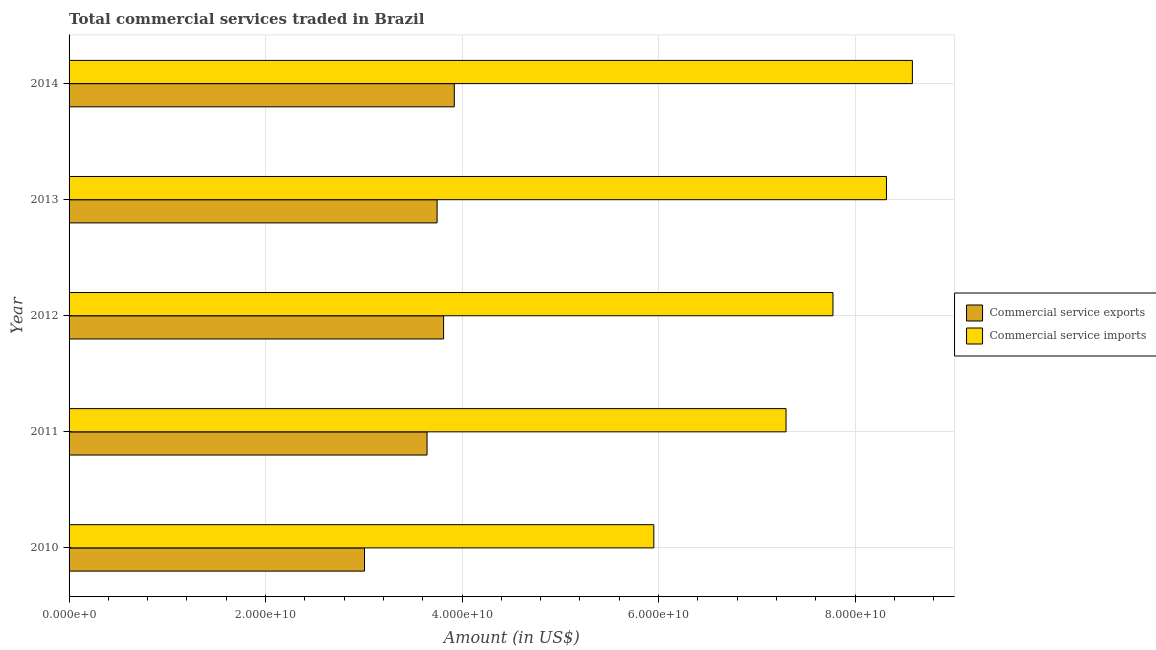How many different coloured bars are there?
Offer a very short reply. 2. Are the number of bars per tick equal to the number of legend labels?
Offer a terse response. Yes. Are the number of bars on each tick of the Y-axis equal?
Provide a short and direct response. Yes. How many bars are there on the 1st tick from the top?
Offer a terse response. 2. How many bars are there on the 4th tick from the bottom?
Make the answer very short. 2. What is the label of the 2nd group of bars from the top?
Provide a succinct answer. 2013. What is the amount of commercial service exports in 2010?
Give a very brief answer. 3.01e+1. Across all years, what is the maximum amount of commercial service imports?
Make the answer very short. 8.58e+1. Across all years, what is the minimum amount of commercial service exports?
Make the answer very short. 3.01e+1. In which year was the amount of commercial service imports maximum?
Provide a short and direct response. 2014. In which year was the amount of commercial service imports minimum?
Provide a succinct answer. 2010. What is the total amount of commercial service exports in the graph?
Ensure brevity in your answer.  1.81e+11. What is the difference between the amount of commercial service exports in 2011 and that in 2013?
Offer a very short reply. -1.02e+09. What is the difference between the amount of commercial service exports in 2014 and the amount of commercial service imports in 2011?
Provide a short and direct response. -3.38e+1. What is the average amount of commercial service exports per year?
Offer a very short reply. 3.63e+1. In the year 2014, what is the difference between the amount of commercial service exports and amount of commercial service imports?
Ensure brevity in your answer.  -4.66e+1. In how many years, is the amount of commercial service exports greater than 28000000000 US$?
Provide a short and direct response. 5. What is the ratio of the amount of commercial service imports in 2010 to that in 2014?
Provide a short and direct response. 0.69. Is the amount of commercial service imports in 2011 less than that in 2013?
Give a very brief answer. Yes. Is the difference between the amount of commercial service exports in 2011 and 2014 greater than the difference between the amount of commercial service imports in 2011 and 2014?
Provide a short and direct response. Yes. What is the difference between the highest and the second highest amount of commercial service exports?
Your answer should be compact. 1.09e+09. What is the difference between the highest and the lowest amount of commercial service imports?
Make the answer very short. 2.63e+1. In how many years, is the amount of commercial service imports greater than the average amount of commercial service imports taken over all years?
Give a very brief answer. 3. What does the 2nd bar from the top in 2012 represents?
Make the answer very short. Commercial service exports. What does the 2nd bar from the bottom in 2014 represents?
Provide a succinct answer. Commercial service imports. How many bars are there?
Your answer should be very brief. 10. How many years are there in the graph?
Provide a succinct answer. 5. What is the difference between two consecutive major ticks on the X-axis?
Your answer should be compact. 2.00e+1. Are the values on the major ticks of X-axis written in scientific E-notation?
Your response must be concise. Yes. Does the graph contain any zero values?
Your answer should be compact. No. Does the graph contain grids?
Your response must be concise. Yes. How many legend labels are there?
Offer a terse response. 2. How are the legend labels stacked?
Your answer should be compact. Vertical. What is the title of the graph?
Offer a terse response. Total commercial services traded in Brazil. Does "Health Care" appear as one of the legend labels in the graph?
Provide a short and direct response. No. What is the label or title of the X-axis?
Provide a succinct answer. Amount (in US$). What is the label or title of the Y-axis?
Your response must be concise. Year. What is the Amount (in US$) of Commercial service exports in 2010?
Make the answer very short. 3.01e+1. What is the Amount (in US$) in Commercial service imports in 2010?
Provide a short and direct response. 5.95e+1. What is the Amount (in US$) in Commercial service exports in 2011?
Offer a terse response. 3.64e+1. What is the Amount (in US$) of Commercial service imports in 2011?
Provide a succinct answer. 7.30e+1. What is the Amount (in US$) of Commercial service exports in 2012?
Offer a very short reply. 3.81e+1. What is the Amount (in US$) in Commercial service imports in 2012?
Give a very brief answer. 7.78e+1. What is the Amount (in US$) in Commercial service exports in 2013?
Provide a short and direct response. 3.75e+1. What is the Amount (in US$) in Commercial service imports in 2013?
Your response must be concise. 8.32e+1. What is the Amount (in US$) in Commercial service exports in 2014?
Offer a terse response. 3.92e+1. What is the Amount (in US$) in Commercial service imports in 2014?
Your answer should be very brief. 8.58e+1. Across all years, what is the maximum Amount (in US$) of Commercial service exports?
Ensure brevity in your answer.  3.92e+1. Across all years, what is the maximum Amount (in US$) in Commercial service imports?
Ensure brevity in your answer.  8.58e+1. Across all years, what is the minimum Amount (in US$) of Commercial service exports?
Give a very brief answer. 3.01e+1. Across all years, what is the minimum Amount (in US$) in Commercial service imports?
Provide a succinct answer. 5.95e+1. What is the total Amount (in US$) in Commercial service exports in the graph?
Your answer should be very brief. 1.81e+11. What is the total Amount (in US$) in Commercial service imports in the graph?
Provide a short and direct response. 3.79e+11. What is the difference between the Amount (in US$) in Commercial service exports in 2010 and that in 2011?
Make the answer very short. -6.36e+09. What is the difference between the Amount (in US$) in Commercial service imports in 2010 and that in 2011?
Provide a succinct answer. -1.35e+1. What is the difference between the Amount (in US$) in Commercial service exports in 2010 and that in 2012?
Offer a very short reply. -8.05e+09. What is the difference between the Amount (in US$) of Commercial service imports in 2010 and that in 2012?
Provide a succinct answer. -1.82e+1. What is the difference between the Amount (in US$) in Commercial service exports in 2010 and that in 2013?
Offer a very short reply. -7.39e+09. What is the difference between the Amount (in US$) in Commercial service imports in 2010 and that in 2013?
Your response must be concise. -2.37e+1. What is the difference between the Amount (in US$) in Commercial service exports in 2010 and that in 2014?
Your answer should be compact. -9.14e+09. What is the difference between the Amount (in US$) of Commercial service imports in 2010 and that in 2014?
Provide a succinct answer. -2.63e+1. What is the difference between the Amount (in US$) of Commercial service exports in 2011 and that in 2012?
Keep it short and to the point. -1.69e+09. What is the difference between the Amount (in US$) of Commercial service imports in 2011 and that in 2012?
Offer a very short reply. -4.77e+09. What is the difference between the Amount (in US$) in Commercial service exports in 2011 and that in 2013?
Your answer should be compact. -1.02e+09. What is the difference between the Amount (in US$) in Commercial service imports in 2011 and that in 2013?
Provide a short and direct response. -1.02e+1. What is the difference between the Amount (in US$) of Commercial service exports in 2011 and that in 2014?
Offer a terse response. -2.77e+09. What is the difference between the Amount (in US$) of Commercial service imports in 2011 and that in 2014?
Provide a short and direct response. -1.29e+1. What is the difference between the Amount (in US$) of Commercial service exports in 2012 and that in 2013?
Offer a very short reply. 6.62e+08. What is the difference between the Amount (in US$) in Commercial service imports in 2012 and that in 2013?
Make the answer very short. -5.44e+09. What is the difference between the Amount (in US$) of Commercial service exports in 2012 and that in 2014?
Offer a very short reply. -1.09e+09. What is the difference between the Amount (in US$) of Commercial service imports in 2012 and that in 2014?
Give a very brief answer. -8.08e+09. What is the difference between the Amount (in US$) of Commercial service exports in 2013 and that in 2014?
Offer a very short reply. -1.75e+09. What is the difference between the Amount (in US$) of Commercial service imports in 2013 and that in 2014?
Your answer should be compact. -2.64e+09. What is the difference between the Amount (in US$) of Commercial service exports in 2010 and the Amount (in US$) of Commercial service imports in 2011?
Give a very brief answer. -4.29e+1. What is the difference between the Amount (in US$) of Commercial service exports in 2010 and the Amount (in US$) of Commercial service imports in 2012?
Keep it short and to the point. -4.77e+1. What is the difference between the Amount (in US$) in Commercial service exports in 2010 and the Amount (in US$) in Commercial service imports in 2013?
Offer a very short reply. -5.31e+1. What is the difference between the Amount (in US$) in Commercial service exports in 2010 and the Amount (in US$) in Commercial service imports in 2014?
Make the answer very short. -5.58e+1. What is the difference between the Amount (in US$) in Commercial service exports in 2011 and the Amount (in US$) in Commercial service imports in 2012?
Keep it short and to the point. -4.13e+1. What is the difference between the Amount (in US$) of Commercial service exports in 2011 and the Amount (in US$) of Commercial service imports in 2013?
Offer a very short reply. -4.68e+1. What is the difference between the Amount (in US$) in Commercial service exports in 2011 and the Amount (in US$) in Commercial service imports in 2014?
Offer a terse response. -4.94e+1. What is the difference between the Amount (in US$) of Commercial service exports in 2012 and the Amount (in US$) of Commercial service imports in 2013?
Keep it short and to the point. -4.51e+1. What is the difference between the Amount (in US$) of Commercial service exports in 2012 and the Amount (in US$) of Commercial service imports in 2014?
Your response must be concise. -4.77e+1. What is the difference between the Amount (in US$) in Commercial service exports in 2013 and the Amount (in US$) in Commercial service imports in 2014?
Keep it short and to the point. -4.84e+1. What is the average Amount (in US$) in Commercial service exports per year?
Give a very brief answer. 3.63e+1. What is the average Amount (in US$) of Commercial service imports per year?
Your answer should be compact. 7.59e+1. In the year 2010, what is the difference between the Amount (in US$) in Commercial service exports and Amount (in US$) in Commercial service imports?
Your answer should be compact. -2.94e+1. In the year 2011, what is the difference between the Amount (in US$) in Commercial service exports and Amount (in US$) in Commercial service imports?
Make the answer very short. -3.65e+1. In the year 2012, what is the difference between the Amount (in US$) of Commercial service exports and Amount (in US$) of Commercial service imports?
Your answer should be very brief. -3.96e+1. In the year 2013, what is the difference between the Amount (in US$) in Commercial service exports and Amount (in US$) in Commercial service imports?
Provide a short and direct response. -4.57e+1. In the year 2014, what is the difference between the Amount (in US$) of Commercial service exports and Amount (in US$) of Commercial service imports?
Offer a terse response. -4.66e+1. What is the ratio of the Amount (in US$) of Commercial service exports in 2010 to that in 2011?
Ensure brevity in your answer.  0.83. What is the ratio of the Amount (in US$) in Commercial service imports in 2010 to that in 2011?
Offer a very short reply. 0.82. What is the ratio of the Amount (in US$) of Commercial service exports in 2010 to that in 2012?
Ensure brevity in your answer.  0.79. What is the ratio of the Amount (in US$) of Commercial service imports in 2010 to that in 2012?
Ensure brevity in your answer.  0.77. What is the ratio of the Amount (in US$) in Commercial service exports in 2010 to that in 2013?
Your response must be concise. 0.8. What is the ratio of the Amount (in US$) in Commercial service imports in 2010 to that in 2013?
Your answer should be compact. 0.72. What is the ratio of the Amount (in US$) of Commercial service exports in 2010 to that in 2014?
Your response must be concise. 0.77. What is the ratio of the Amount (in US$) of Commercial service imports in 2010 to that in 2014?
Offer a terse response. 0.69. What is the ratio of the Amount (in US$) of Commercial service exports in 2011 to that in 2012?
Your answer should be very brief. 0.96. What is the ratio of the Amount (in US$) in Commercial service imports in 2011 to that in 2012?
Your answer should be very brief. 0.94. What is the ratio of the Amount (in US$) in Commercial service exports in 2011 to that in 2013?
Your answer should be compact. 0.97. What is the ratio of the Amount (in US$) in Commercial service imports in 2011 to that in 2013?
Ensure brevity in your answer.  0.88. What is the ratio of the Amount (in US$) of Commercial service exports in 2011 to that in 2014?
Your answer should be compact. 0.93. What is the ratio of the Amount (in US$) of Commercial service imports in 2011 to that in 2014?
Offer a terse response. 0.85. What is the ratio of the Amount (in US$) in Commercial service exports in 2012 to that in 2013?
Offer a very short reply. 1.02. What is the ratio of the Amount (in US$) of Commercial service imports in 2012 to that in 2013?
Your answer should be compact. 0.93. What is the ratio of the Amount (in US$) of Commercial service exports in 2012 to that in 2014?
Your answer should be compact. 0.97. What is the ratio of the Amount (in US$) of Commercial service imports in 2012 to that in 2014?
Your answer should be very brief. 0.91. What is the ratio of the Amount (in US$) of Commercial service exports in 2013 to that in 2014?
Give a very brief answer. 0.96. What is the ratio of the Amount (in US$) of Commercial service imports in 2013 to that in 2014?
Offer a very short reply. 0.97. What is the difference between the highest and the second highest Amount (in US$) of Commercial service exports?
Offer a terse response. 1.09e+09. What is the difference between the highest and the second highest Amount (in US$) of Commercial service imports?
Your answer should be very brief. 2.64e+09. What is the difference between the highest and the lowest Amount (in US$) of Commercial service exports?
Your response must be concise. 9.14e+09. What is the difference between the highest and the lowest Amount (in US$) in Commercial service imports?
Your answer should be compact. 2.63e+1. 